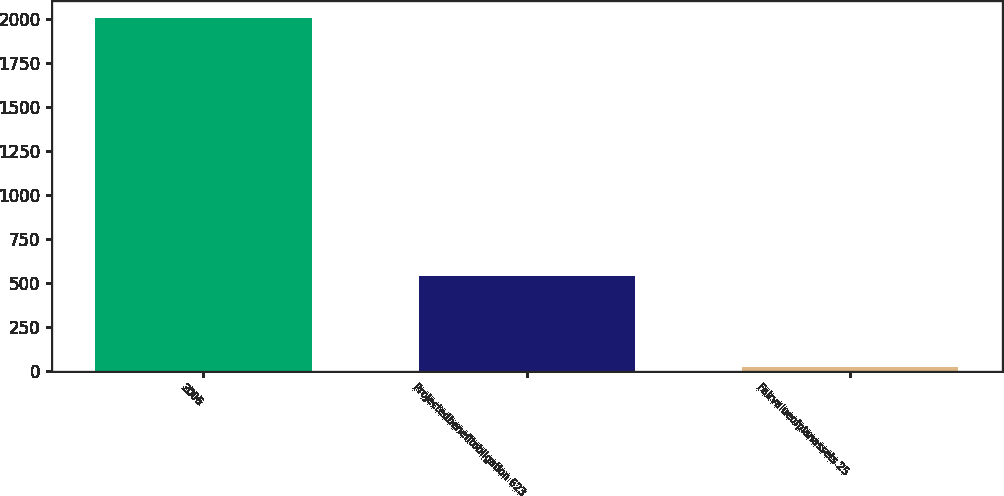<chart> <loc_0><loc_0><loc_500><loc_500><bar_chart><fcel>2006<fcel>Projectedbenefitobligation 623<fcel>Fairvalueofplanassets 25<nl><fcel>2005<fcel>538<fcel>19<nl></chart> 